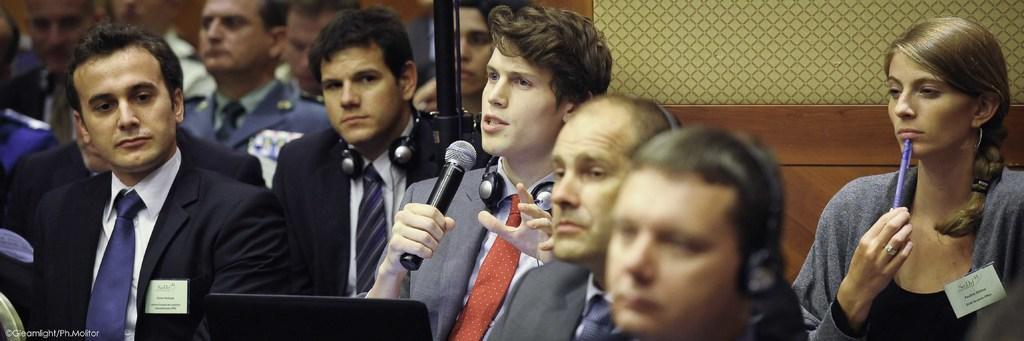Describe this image in one or two sentences. In this picture we can see there are groups of people and a man is holding a microphone and explaining something and the woman is holding a pen. Behind the people it is looking like a wooden wall. On the image there is a watermark. 